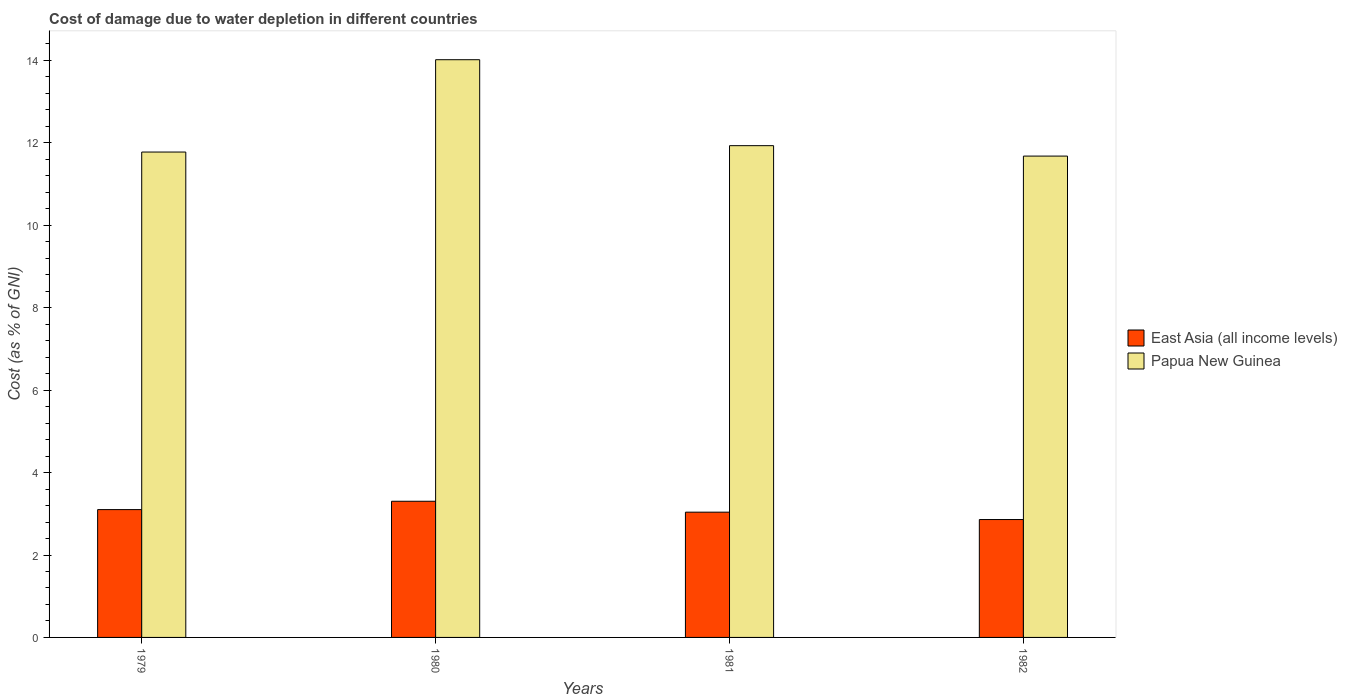How many different coloured bars are there?
Ensure brevity in your answer.  2. Are the number of bars on each tick of the X-axis equal?
Keep it short and to the point. Yes. How many bars are there on the 2nd tick from the right?
Keep it short and to the point. 2. What is the label of the 1st group of bars from the left?
Ensure brevity in your answer.  1979. What is the cost of damage caused due to water depletion in East Asia (all income levels) in 1980?
Your answer should be very brief. 3.3. Across all years, what is the maximum cost of damage caused due to water depletion in East Asia (all income levels)?
Ensure brevity in your answer.  3.3. Across all years, what is the minimum cost of damage caused due to water depletion in Papua New Guinea?
Your response must be concise. 11.68. In which year was the cost of damage caused due to water depletion in Papua New Guinea minimum?
Offer a terse response. 1982. What is the total cost of damage caused due to water depletion in Papua New Guinea in the graph?
Your answer should be very brief. 49.41. What is the difference between the cost of damage caused due to water depletion in East Asia (all income levels) in 1980 and that in 1981?
Offer a very short reply. 0.26. What is the difference between the cost of damage caused due to water depletion in East Asia (all income levels) in 1982 and the cost of damage caused due to water depletion in Papua New Guinea in 1979?
Keep it short and to the point. -8.92. What is the average cost of damage caused due to water depletion in Papua New Guinea per year?
Keep it short and to the point. 12.35. In the year 1980, what is the difference between the cost of damage caused due to water depletion in Papua New Guinea and cost of damage caused due to water depletion in East Asia (all income levels)?
Your response must be concise. 10.71. In how many years, is the cost of damage caused due to water depletion in East Asia (all income levels) greater than 0.4 %?
Give a very brief answer. 4. What is the ratio of the cost of damage caused due to water depletion in East Asia (all income levels) in 1979 to that in 1980?
Make the answer very short. 0.94. What is the difference between the highest and the second highest cost of damage caused due to water depletion in East Asia (all income levels)?
Offer a terse response. 0.2. What is the difference between the highest and the lowest cost of damage caused due to water depletion in East Asia (all income levels)?
Provide a succinct answer. 0.44. In how many years, is the cost of damage caused due to water depletion in East Asia (all income levels) greater than the average cost of damage caused due to water depletion in East Asia (all income levels) taken over all years?
Ensure brevity in your answer.  2. What does the 2nd bar from the left in 1982 represents?
Provide a short and direct response. Papua New Guinea. What does the 1st bar from the right in 1981 represents?
Your answer should be very brief. Papua New Guinea. Does the graph contain grids?
Your answer should be compact. No. Where does the legend appear in the graph?
Keep it short and to the point. Center right. What is the title of the graph?
Your answer should be very brief. Cost of damage due to water depletion in different countries. Does "Malaysia" appear as one of the legend labels in the graph?
Ensure brevity in your answer.  No. What is the label or title of the Y-axis?
Ensure brevity in your answer.  Cost (as % of GNI). What is the Cost (as % of GNI) in East Asia (all income levels) in 1979?
Ensure brevity in your answer.  3.1. What is the Cost (as % of GNI) of Papua New Guinea in 1979?
Give a very brief answer. 11.78. What is the Cost (as % of GNI) in East Asia (all income levels) in 1980?
Keep it short and to the point. 3.3. What is the Cost (as % of GNI) in Papua New Guinea in 1980?
Offer a very short reply. 14.02. What is the Cost (as % of GNI) in East Asia (all income levels) in 1981?
Your response must be concise. 3.04. What is the Cost (as % of GNI) in Papua New Guinea in 1981?
Offer a terse response. 11.93. What is the Cost (as % of GNI) of East Asia (all income levels) in 1982?
Your response must be concise. 2.86. What is the Cost (as % of GNI) in Papua New Guinea in 1982?
Keep it short and to the point. 11.68. Across all years, what is the maximum Cost (as % of GNI) in East Asia (all income levels)?
Offer a terse response. 3.3. Across all years, what is the maximum Cost (as % of GNI) in Papua New Guinea?
Offer a very short reply. 14.02. Across all years, what is the minimum Cost (as % of GNI) in East Asia (all income levels)?
Make the answer very short. 2.86. Across all years, what is the minimum Cost (as % of GNI) of Papua New Guinea?
Offer a very short reply. 11.68. What is the total Cost (as % of GNI) in East Asia (all income levels) in the graph?
Your response must be concise. 12.31. What is the total Cost (as % of GNI) in Papua New Guinea in the graph?
Your response must be concise. 49.41. What is the difference between the Cost (as % of GNI) of East Asia (all income levels) in 1979 and that in 1980?
Your answer should be very brief. -0.2. What is the difference between the Cost (as % of GNI) in Papua New Guinea in 1979 and that in 1980?
Ensure brevity in your answer.  -2.24. What is the difference between the Cost (as % of GNI) in East Asia (all income levels) in 1979 and that in 1981?
Ensure brevity in your answer.  0.06. What is the difference between the Cost (as % of GNI) in Papua New Guinea in 1979 and that in 1981?
Offer a very short reply. -0.15. What is the difference between the Cost (as % of GNI) in East Asia (all income levels) in 1979 and that in 1982?
Your answer should be very brief. 0.24. What is the difference between the Cost (as % of GNI) of Papua New Guinea in 1979 and that in 1982?
Keep it short and to the point. 0.1. What is the difference between the Cost (as % of GNI) of East Asia (all income levels) in 1980 and that in 1981?
Your response must be concise. 0.26. What is the difference between the Cost (as % of GNI) in Papua New Guinea in 1980 and that in 1981?
Ensure brevity in your answer.  2.09. What is the difference between the Cost (as % of GNI) of East Asia (all income levels) in 1980 and that in 1982?
Your answer should be compact. 0.44. What is the difference between the Cost (as % of GNI) in Papua New Guinea in 1980 and that in 1982?
Provide a succinct answer. 2.34. What is the difference between the Cost (as % of GNI) of East Asia (all income levels) in 1981 and that in 1982?
Ensure brevity in your answer.  0.18. What is the difference between the Cost (as % of GNI) of Papua New Guinea in 1981 and that in 1982?
Your answer should be compact. 0.25. What is the difference between the Cost (as % of GNI) of East Asia (all income levels) in 1979 and the Cost (as % of GNI) of Papua New Guinea in 1980?
Your response must be concise. -10.92. What is the difference between the Cost (as % of GNI) of East Asia (all income levels) in 1979 and the Cost (as % of GNI) of Papua New Guinea in 1981?
Give a very brief answer. -8.83. What is the difference between the Cost (as % of GNI) in East Asia (all income levels) in 1979 and the Cost (as % of GNI) in Papua New Guinea in 1982?
Make the answer very short. -8.58. What is the difference between the Cost (as % of GNI) of East Asia (all income levels) in 1980 and the Cost (as % of GNI) of Papua New Guinea in 1981?
Make the answer very short. -8.63. What is the difference between the Cost (as % of GNI) of East Asia (all income levels) in 1980 and the Cost (as % of GNI) of Papua New Guinea in 1982?
Your answer should be very brief. -8.38. What is the difference between the Cost (as % of GNI) of East Asia (all income levels) in 1981 and the Cost (as % of GNI) of Papua New Guinea in 1982?
Your answer should be very brief. -8.64. What is the average Cost (as % of GNI) in East Asia (all income levels) per year?
Provide a short and direct response. 3.08. What is the average Cost (as % of GNI) of Papua New Guinea per year?
Your answer should be very brief. 12.35. In the year 1979, what is the difference between the Cost (as % of GNI) in East Asia (all income levels) and Cost (as % of GNI) in Papua New Guinea?
Provide a short and direct response. -8.68. In the year 1980, what is the difference between the Cost (as % of GNI) of East Asia (all income levels) and Cost (as % of GNI) of Papua New Guinea?
Offer a very short reply. -10.71. In the year 1981, what is the difference between the Cost (as % of GNI) in East Asia (all income levels) and Cost (as % of GNI) in Papua New Guinea?
Offer a very short reply. -8.89. In the year 1982, what is the difference between the Cost (as % of GNI) in East Asia (all income levels) and Cost (as % of GNI) in Papua New Guinea?
Offer a very short reply. -8.82. What is the ratio of the Cost (as % of GNI) in East Asia (all income levels) in 1979 to that in 1980?
Offer a terse response. 0.94. What is the ratio of the Cost (as % of GNI) of Papua New Guinea in 1979 to that in 1980?
Ensure brevity in your answer.  0.84. What is the ratio of the Cost (as % of GNI) in East Asia (all income levels) in 1979 to that in 1981?
Provide a short and direct response. 1.02. What is the ratio of the Cost (as % of GNI) in Papua New Guinea in 1979 to that in 1981?
Your answer should be compact. 0.99. What is the ratio of the Cost (as % of GNI) in East Asia (all income levels) in 1979 to that in 1982?
Provide a succinct answer. 1.08. What is the ratio of the Cost (as % of GNI) of Papua New Guinea in 1979 to that in 1982?
Provide a succinct answer. 1.01. What is the ratio of the Cost (as % of GNI) of East Asia (all income levels) in 1980 to that in 1981?
Provide a short and direct response. 1.09. What is the ratio of the Cost (as % of GNI) of Papua New Guinea in 1980 to that in 1981?
Provide a succinct answer. 1.17. What is the ratio of the Cost (as % of GNI) of East Asia (all income levels) in 1980 to that in 1982?
Offer a very short reply. 1.16. What is the ratio of the Cost (as % of GNI) in Papua New Guinea in 1980 to that in 1982?
Offer a very short reply. 1.2. What is the ratio of the Cost (as % of GNI) in Papua New Guinea in 1981 to that in 1982?
Offer a very short reply. 1.02. What is the difference between the highest and the second highest Cost (as % of GNI) in East Asia (all income levels)?
Offer a terse response. 0.2. What is the difference between the highest and the second highest Cost (as % of GNI) in Papua New Guinea?
Give a very brief answer. 2.09. What is the difference between the highest and the lowest Cost (as % of GNI) of East Asia (all income levels)?
Give a very brief answer. 0.44. What is the difference between the highest and the lowest Cost (as % of GNI) in Papua New Guinea?
Your answer should be very brief. 2.34. 